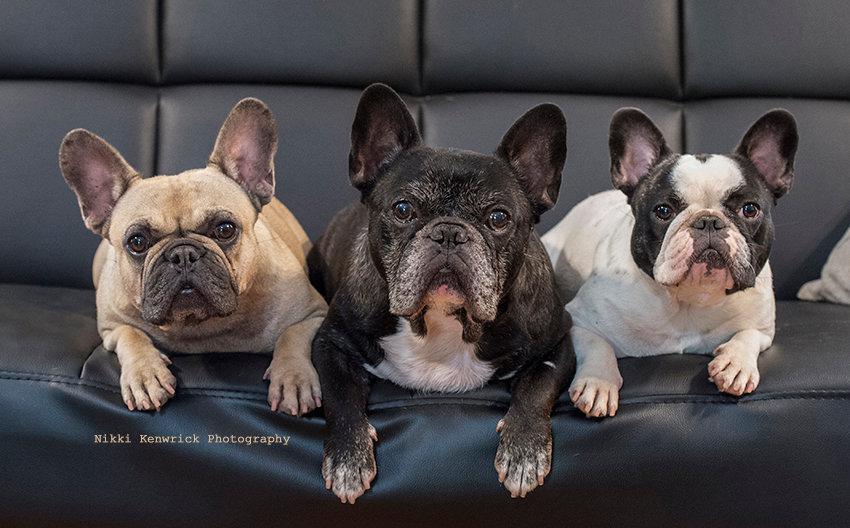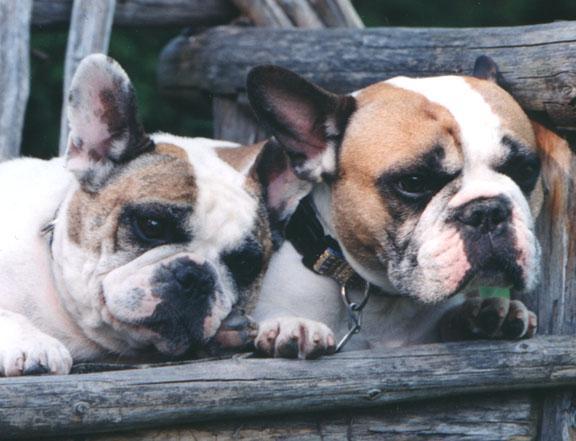The first image is the image on the left, the second image is the image on the right. Assess this claim about the two images: "Exactly six little dogs are shown.". Correct or not? Answer yes or no. No. The first image is the image on the left, the second image is the image on the right. Assess this claim about the two images: "There are six dogs". Correct or not? Answer yes or no. No. 